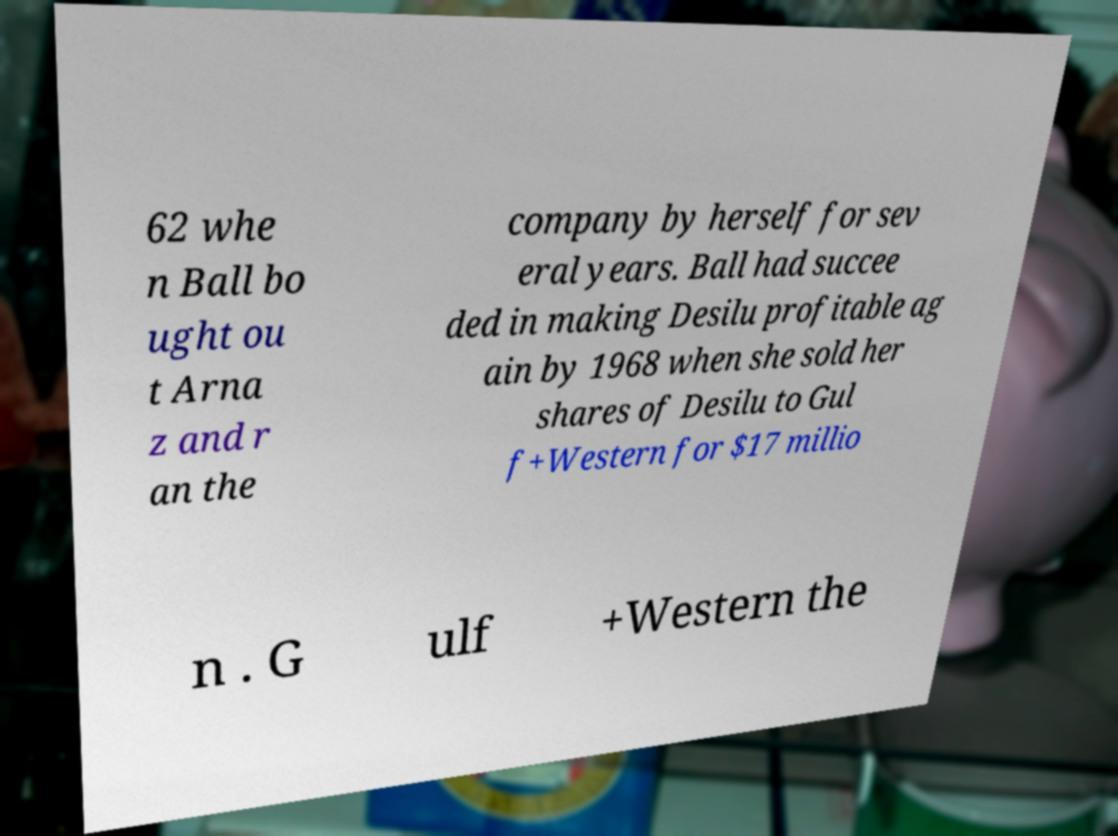Please identify and transcribe the text found in this image. 62 whe n Ball bo ught ou t Arna z and r an the company by herself for sev eral years. Ball had succee ded in making Desilu profitable ag ain by 1968 when she sold her shares of Desilu to Gul f+Western for $17 millio n . G ulf +Western the 